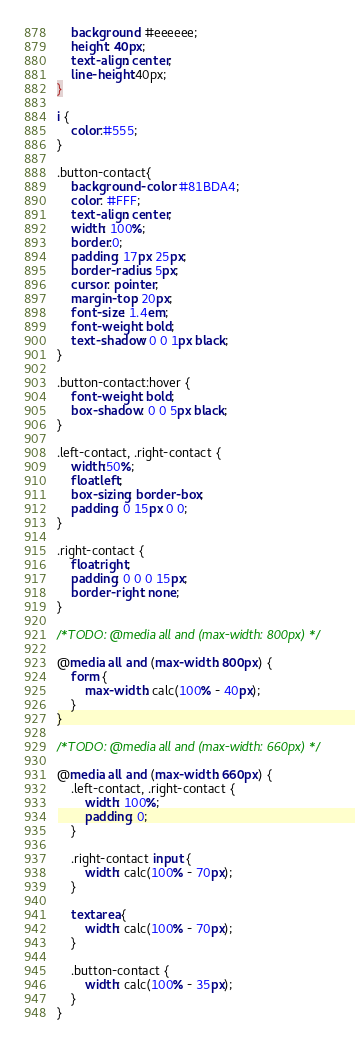Convert code to text. <code><loc_0><loc_0><loc_500><loc_500><_CSS_>    background: #eeeeee;
    height: 40px;
    text-align: center;
    line-height:40px;
}

i {
    color:#555;
}

.button-contact{
    background-color: #81BDA4;
    color: #FFF;
    text-align: center;
    width: 100%;
    border:0;
    padding: 17px 25px;
    border-radius: 5px;
    cursor: pointer;
    margin-top: 20px;
    font-size: 1.4em;
    font-weight: bold;
    text-shadow: 0 0 1px black;
}

.button-contact:hover {
    font-weight: bold;
    box-shadow: 0 0 5px black;
}

.left-contact, .right-contact {
    width:50%;
    float:left;
    box-sizing: border-box;
    padding: 0 15px 0 0;
}

.right-contact {
    float:right;
    padding: 0 0 0 15px;
    border-right: none;
}

/*TODO: @media all and (max-width: 800px) */

@media all and (max-width: 800px) {
    form {
        max-width: calc(100% - 40px);
    }
}

/*TODO: @media all and (max-width: 660px) */

@media all and (max-width: 660px) {
    .left-contact, .right-contact {
        width: 100%;
        padding: 0;
    }

    .right-contact input {
        width: calc(100% - 70px);
    }

    textarea {
        width: calc(100% - 70px);
    }

    .button-contact {
        width: calc(100% - 35px);
    }
}</code> 